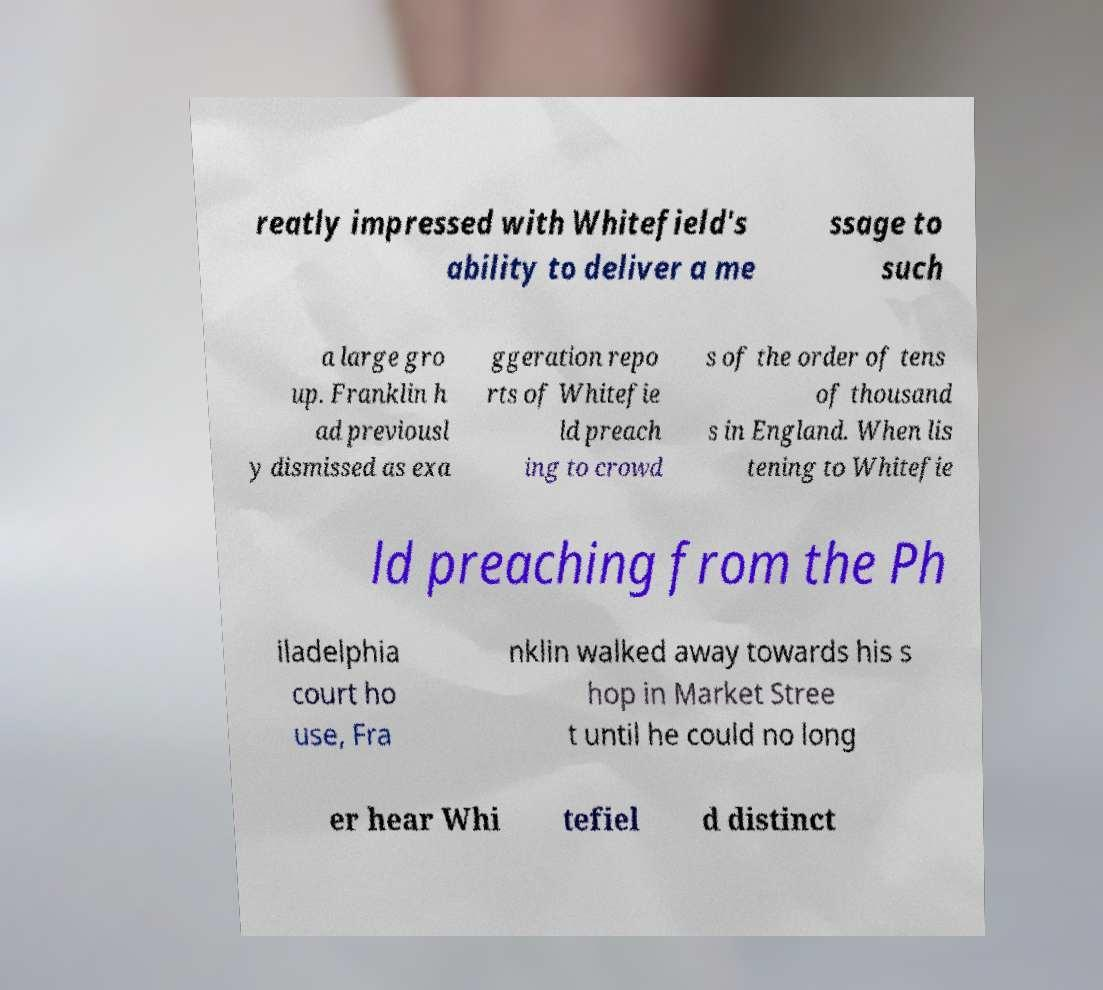Can you read and provide the text displayed in the image?This photo seems to have some interesting text. Can you extract and type it out for me? reatly impressed with Whitefield's ability to deliver a me ssage to such a large gro up. Franklin h ad previousl y dismissed as exa ggeration repo rts of Whitefie ld preach ing to crowd s of the order of tens of thousand s in England. When lis tening to Whitefie ld preaching from the Ph iladelphia court ho use, Fra nklin walked away towards his s hop in Market Stree t until he could no long er hear Whi tefiel d distinct 